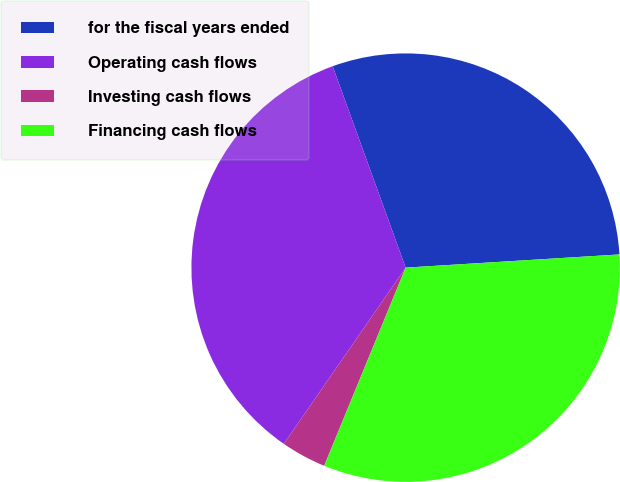Convert chart. <chart><loc_0><loc_0><loc_500><loc_500><pie_chart><fcel>for the fiscal years ended<fcel>Operating cash flows<fcel>Investing cash flows<fcel>Financing cash flows<nl><fcel>29.55%<fcel>34.84%<fcel>3.42%<fcel>32.19%<nl></chart> 